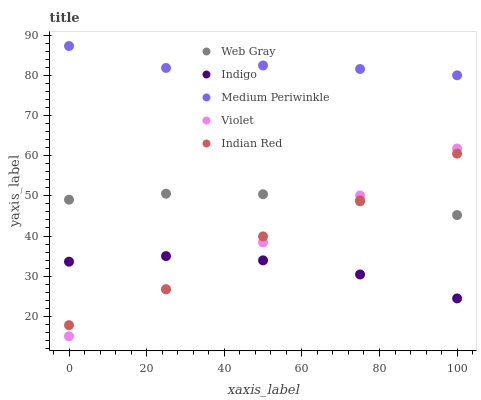Does Indigo have the minimum area under the curve?
Answer yes or no. Yes. Does Medium Periwinkle have the maximum area under the curve?
Answer yes or no. Yes. Does Web Gray have the minimum area under the curve?
Answer yes or no. No. Does Web Gray have the maximum area under the curve?
Answer yes or no. No. Is Violet the smoothest?
Answer yes or no. Yes. Is Indian Red the roughest?
Answer yes or no. Yes. Is Web Gray the smoothest?
Answer yes or no. No. Is Web Gray the roughest?
Answer yes or no. No. Does Violet have the lowest value?
Answer yes or no. Yes. Does Web Gray have the lowest value?
Answer yes or no. No. Does Medium Periwinkle have the highest value?
Answer yes or no. Yes. Does Web Gray have the highest value?
Answer yes or no. No. Is Indigo less than Web Gray?
Answer yes or no. Yes. Is Web Gray greater than Indigo?
Answer yes or no. Yes. Does Violet intersect Indian Red?
Answer yes or no. Yes. Is Violet less than Indian Red?
Answer yes or no. No. Is Violet greater than Indian Red?
Answer yes or no. No. Does Indigo intersect Web Gray?
Answer yes or no. No. 